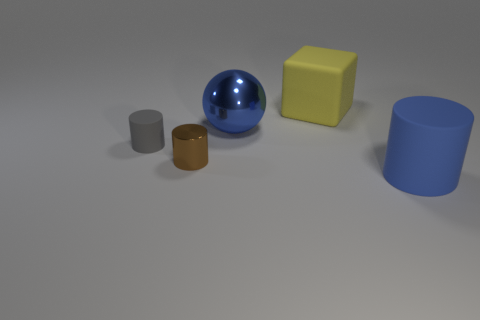What is the color of the tiny metal cylinder?
Ensure brevity in your answer.  Brown. There is a object that is behind the large blue metal ball; what color is it?
Your answer should be compact. Yellow. How many matte objects are behind the metal thing that is behind the brown metal cylinder?
Provide a succinct answer. 1. Does the brown metallic cylinder have the same size as the rubber thing on the left side of the large yellow rubber block?
Provide a succinct answer. Yes. Is there a blue metal sphere that has the same size as the gray cylinder?
Provide a succinct answer. No. How many objects are gray matte things or cyan metal spheres?
Keep it short and to the point. 1. There is a cube that is behind the tiny matte object; is its size the same as the cylinder that is on the right side of the tiny brown metallic cylinder?
Your answer should be compact. Yes. Are there any blue objects that have the same shape as the tiny brown object?
Give a very brief answer. Yes. Are there fewer objects that are in front of the big rubber cylinder than small yellow balls?
Provide a short and direct response. No. Is the big blue rubber thing the same shape as the tiny brown metallic thing?
Offer a terse response. Yes. 